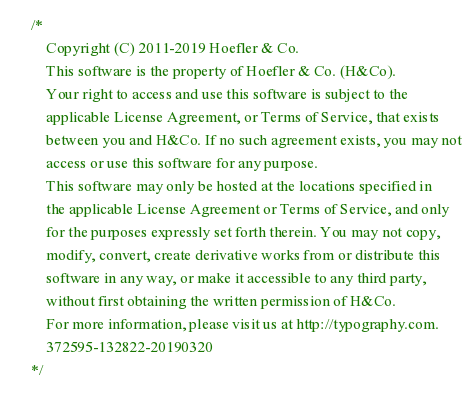Convert code to text. <code><loc_0><loc_0><loc_500><loc_500><_CSS_>
/*
	Copyright (C) 2011-2019 Hoefler & Co.
	This software is the property of Hoefler & Co. (H&Co).
	Your right to access and use this software is subject to the
	applicable License Agreement, or Terms of Service, that exists
	between you and H&Co. If no such agreement exists, you may not
	access or use this software for any purpose.
	This software may only be hosted at the locations specified in
	the applicable License Agreement or Terms of Service, and only
	for the purposes expressly set forth therein. You may not copy,
	modify, convert, create derivative works from or distribute this
	software in any way, or make it accessible to any third party,
	without first obtaining the written permission of H&Co.
	For more information, please visit us at http://typography.com.
	372595-132822-20190320
*/
</code> 